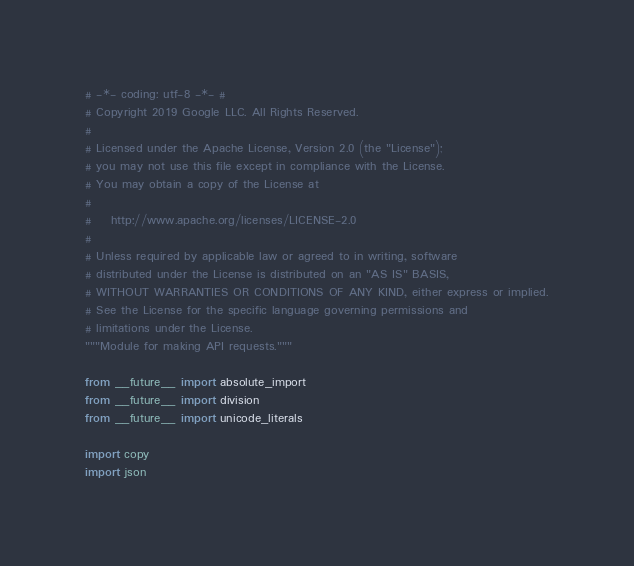<code> <loc_0><loc_0><loc_500><loc_500><_Python_># -*- coding: utf-8 -*- #
# Copyright 2019 Google LLC. All Rights Reserved.
#
# Licensed under the Apache License, Version 2.0 (the "License");
# you may not use this file except in compliance with the License.
# You may obtain a copy of the License at
#
#    http://www.apache.org/licenses/LICENSE-2.0
#
# Unless required by applicable law or agreed to in writing, software
# distributed under the License is distributed on an "AS IS" BASIS,
# WITHOUT WARRANTIES OR CONDITIONS OF ANY KIND, either express or implied.
# See the License for the specific language governing permissions and
# limitations under the License.
"""Module for making API requests."""

from __future__ import absolute_import
from __future__ import division
from __future__ import unicode_literals

import copy
import json
</code> 